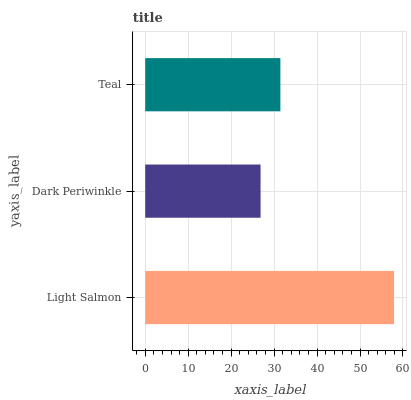Is Dark Periwinkle the minimum?
Answer yes or no. Yes. Is Light Salmon the maximum?
Answer yes or no. Yes. Is Teal the minimum?
Answer yes or no. No. Is Teal the maximum?
Answer yes or no. No. Is Teal greater than Dark Periwinkle?
Answer yes or no. Yes. Is Dark Periwinkle less than Teal?
Answer yes or no. Yes. Is Dark Periwinkle greater than Teal?
Answer yes or no. No. Is Teal less than Dark Periwinkle?
Answer yes or no. No. Is Teal the high median?
Answer yes or no. Yes. Is Teal the low median?
Answer yes or no. Yes. Is Light Salmon the high median?
Answer yes or no. No. Is Dark Periwinkle the low median?
Answer yes or no. No. 